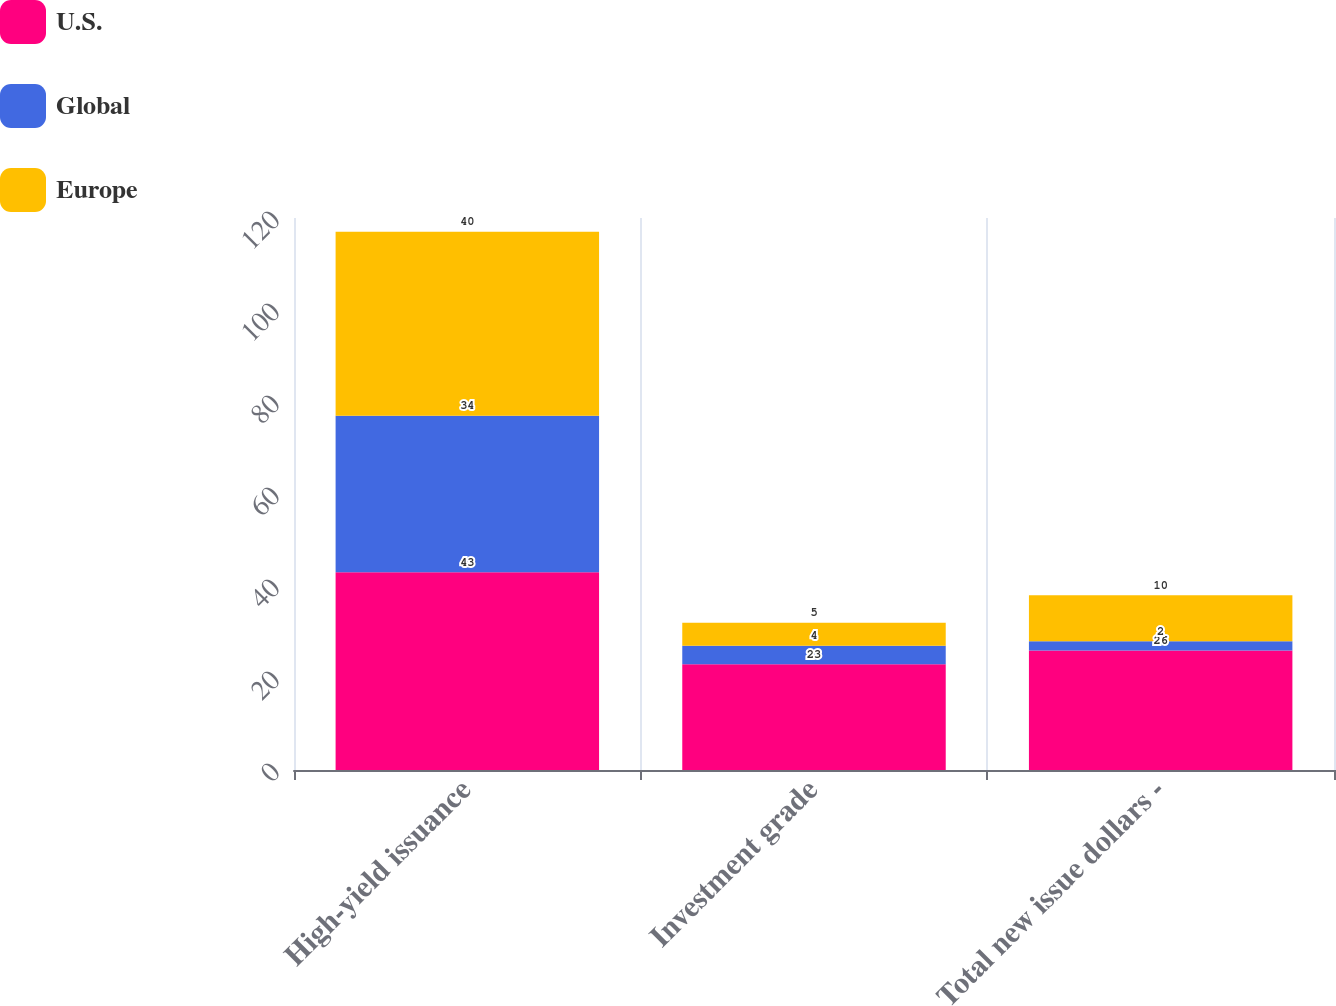Convert chart to OTSL. <chart><loc_0><loc_0><loc_500><loc_500><stacked_bar_chart><ecel><fcel>High-yield issuance<fcel>Investment grade<fcel>Total new issue dollars -<nl><fcel>U.S.<fcel>43<fcel>23<fcel>26<nl><fcel>Global<fcel>34<fcel>4<fcel>2<nl><fcel>Europe<fcel>40<fcel>5<fcel>10<nl></chart> 